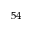Convert formula to latex. <formula><loc_0><loc_0><loc_500><loc_500>^ { 5 4 }</formula> 